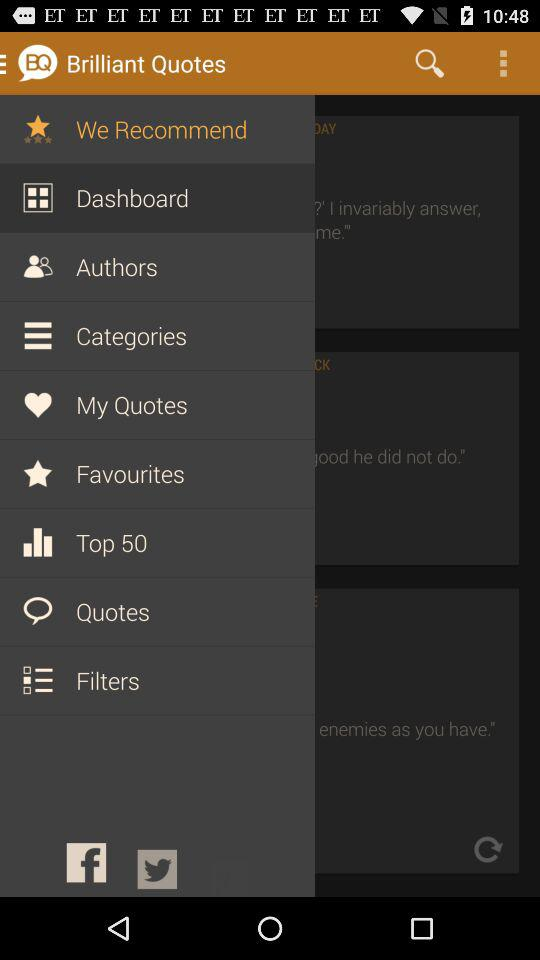How many notifications are there in "Authors"?
When the provided information is insufficient, respond with <no answer>. <no answer> 